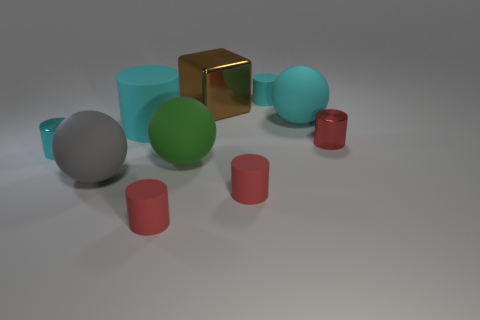Subtract all green spheres. How many cyan cylinders are left? 3 Subtract all cyan shiny cylinders. How many cylinders are left? 5 Subtract 3 cylinders. How many cylinders are left? 3 Subtract all green cylinders. Subtract all red balls. How many cylinders are left? 6 Subtract all spheres. How many objects are left? 7 Subtract all yellow things. Subtract all large gray things. How many objects are left? 9 Add 3 big spheres. How many big spheres are left? 6 Add 9 small cyan metallic cylinders. How many small cyan metallic cylinders exist? 10 Subtract 0 purple spheres. How many objects are left? 10 